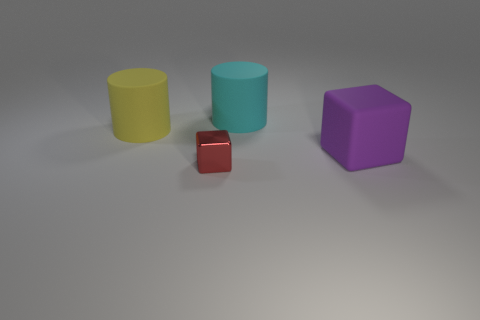Are there any large matte things of the same color as the big cube?
Provide a short and direct response. No. Are there an equal number of large purple matte objects that are left of the big purple matte object and large rubber things?
Provide a short and direct response. No. Do the big rubber cube and the small shiny cube have the same color?
Make the answer very short. No. There is a thing that is in front of the yellow cylinder and behind the tiny block; what size is it?
Provide a succinct answer. Large. There is a cube that is made of the same material as the large cyan object; what is its color?
Offer a terse response. Purple. What number of big cylinders are the same material as the cyan object?
Your response must be concise. 1. Is the number of purple matte blocks that are left of the large purple matte thing the same as the number of small shiny objects right of the big yellow matte cylinder?
Your answer should be very brief. No. Is the shape of the purple rubber thing the same as the thing behind the yellow cylinder?
Your answer should be compact. No. Is there anything else that has the same shape as the big purple thing?
Offer a terse response. Yes. Do the big purple object and the large object that is behind the yellow matte object have the same material?
Offer a very short reply. Yes. 